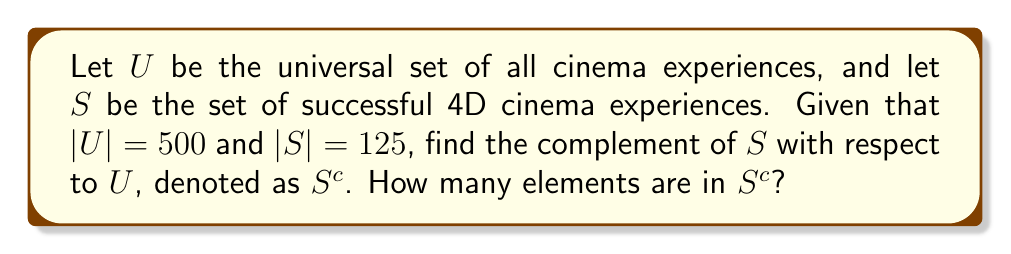Provide a solution to this math problem. To solve this problem, we need to understand the concept of set complement and apply it to the given scenario of 4D cinema experiences.

1. The universal set $U$ represents all cinema experiences, including both 4D and non-4D.
2. Set $S$ represents successful 4D cinema experiences.
3. The complement of $S$, denoted as $S^c$, represents all cinema experiences that are not successful 4D experiences.

To find the number of elements in $S^c$, we can use the following formula:

$$|S^c| = |U| - |S|$$

Where:
- $|U|$ is the number of elements in the universal set
- $|S|$ is the number of elements in the set of successful 4D cinema experiences

Given:
- $|U| = 500$
- $|S| = 125$

Substituting these values into the formula:

$$|S^c| = 500 - 125 = 375$$

Therefore, the complement of $S$ contains 375 elements, which represents all cinema experiences that are not successful 4D experiences. This includes non-4D cinema experiences and unsuccessful 4D cinema experiences.
Answer: $|S^c| = 375$ 